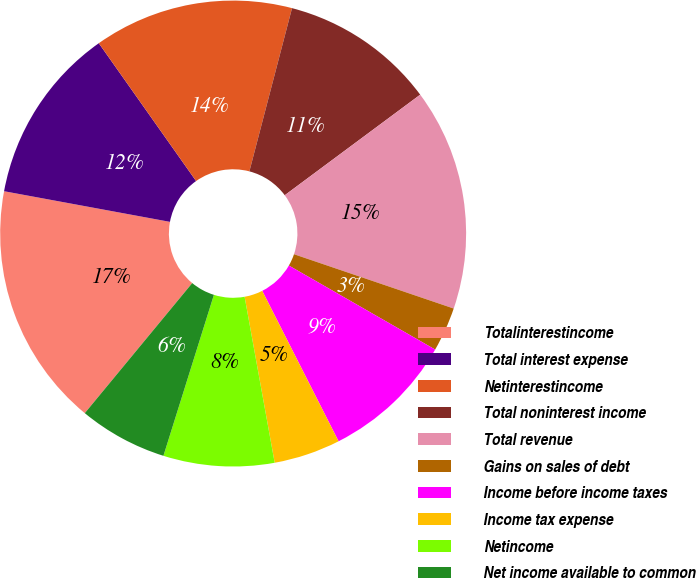<chart> <loc_0><loc_0><loc_500><loc_500><pie_chart><fcel>Totalinterestincome<fcel>Total interest expense<fcel>Netinterestincome<fcel>Total noninterest income<fcel>Total revenue<fcel>Gains on sales of debt<fcel>Income before income taxes<fcel>Income tax expense<fcel>Netincome<fcel>Net income available to common<nl><fcel>16.92%<fcel>12.31%<fcel>13.85%<fcel>10.77%<fcel>15.38%<fcel>3.08%<fcel>9.23%<fcel>4.62%<fcel>7.69%<fcel>6.15%<nl></chart> 